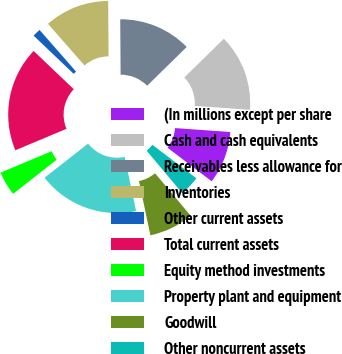Convert chart. <chart><loc_0><loc_0><loc_500><loc_500><pie_chart><fcel>(In millions except per share<fcel>Cash and cash equivalents<fcel>Receivables less allowance for<fcel>Inventories<fcel>Other current assets<fcel>Total current assets<fcel>Equity method investments<fcel>Property plant and equipment<fcel>Goodwill<fcel>Other noncurrent assets<nl><fcel>9.22%<fcel>13.47%<fcel>12.77%<fcel>11.35%<fcel>1.42%<fcel>18.44%<fcel>4.26%<fcel>17.73%<fcel>7.8%<fcel>3.55%<nl></chart> 